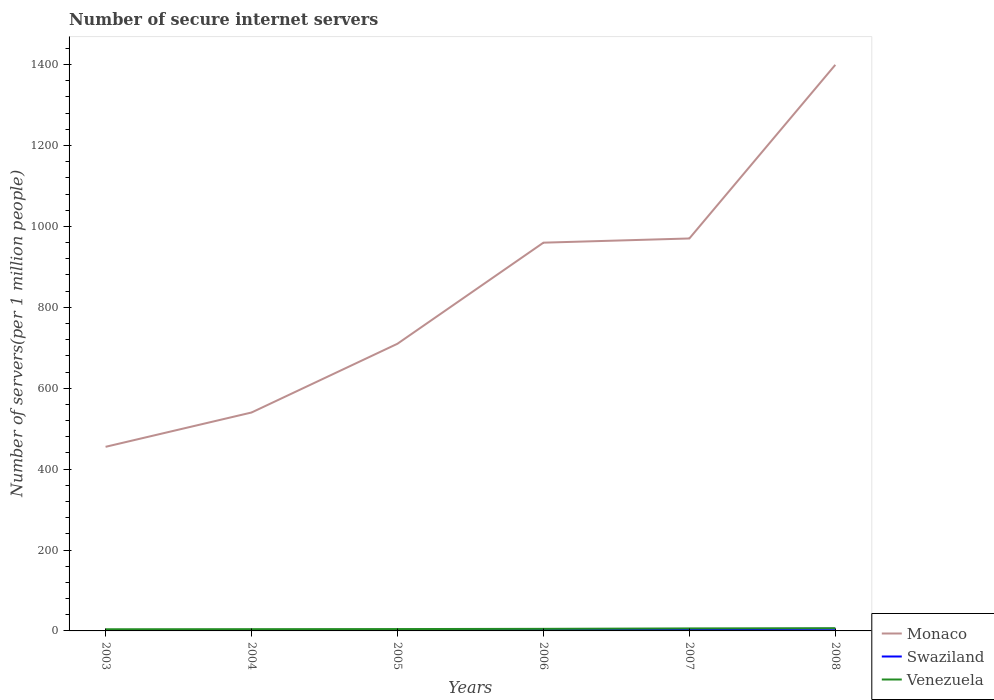How many different coloured lines are there?
Your answer should be compact. 3. Is the number of lines equal to the number of legend labels?
Your answer should be very brief. Yes. Across all years, what is the maximum number of secure internet servers in Swaziland?
Make the answer very short. 1.81. In which year was the number of secure internet servers in Swaziland maximum?
Ensure brevity in your answer.  2005. What is the total number of secure internet servers in Monaco in the graph?
Ensure brevity in your answer.  -10.4. What is the difference between the highest and the second highest number of secure internet servers in Monaco?
Your answer should be very brief. 944.25. What is the difference between the highest and the lowest number of secure internet servers in Venezuela?
Give a very brief answer. 2. Is the number of secure internet servers in Swaziland strictly greater than the number of secure internet servers in Venezuela over the years?
Keep it short and to the point. Yes. How many years are there in the graph?
Your answer should be compact. 6. Are the values on the major ticks of Y-axis written in scientific E-notation?
Offer a very short reply. No. Does the graph contain grids?
Ensure brevity in your answer.  No. Where does the legend appear in the graph?
Give a very brief answer. Bottom right. What is the title of the graph?
Give a very brief answer. Number of secure internet servers. Does "Hungary" appear as one of the legend labels in the graph?
Make the answer very short. No. What is the label or title of the Y-axis?
Your answer should be very brief. Number of servers(per 1 million people). What is the Number of servers(per 1 million people) in Monaco in 2003?
Ensure brevity in your answer.  455.1. What is the Number of servers(per 1 million people) in Swaziland in 2003?
Offer a very short reply. 1.84. What is the Number of servers(per 1 million people) of Venezuela in 2003?
Offer a terse response. 4.1. What is the Number of servers(per 1 million people) of Monaco in 2004?
Offer a terse response. 539.91. What is the Number of servers(per 1 million people) of Swaziland in 2004?
Your answer should be very brief. 1.83. What is the Number of servers(per 1 million people) in Venezuela in 2004?
Your answer should be compact. 4.33. What is the Number of servers(per 1 million people) of Monaco in 2005?
Offer a very short reply. 709.89. What is the Number of servers(per 1 million people) of Swaziland in 2005?
Give a very brief answer. 1.81. What is the Number of servers(per 1 million people) in Venezuela in 2005?
Offer a very short reply. 4.59. What is the Number of servers(per 1 million people) of Monaco in 2006?
Keep it short and to the point. 959.75. What is the Number of servers(per 1 million people) in Swaziland in 2006?
Offer a terse response. 4.47. What is the Number of servers(per 1 million people) in Venezuela in 2006?
Ensure brevity in your answer.  5.14. What is the Number of servers(per 1 million people) in Monaco in 2007?
Provide a succinct answer. 970.15. What is the Number of servers(per 1 million people) in Swaziland in 2007?
Offer a terse response. 4.41. What is the Number of servers(per 1 million people) of Venezuela in 2007?
Offer a very short reply. 6.18. What is the Number of servers(per 1 million people) in Monaco in 2008?
Your answer should be very brief. 1399.35. What is the Number of servers(per 1 million people) of Swaziland in 2008?
Offer a very short reply. 5.2. What is the Number of servers(per 1 million people) of Venezuela in 2008?
Give a very brief answer. 6.72. Across all years, what is the maximum Number of servers(per 1 million people) in Monaco?
Offer a terse response. 1399.35. Across all years, what is the maximum Number of servers(per 1 million people) in Swaziland?
Give a very brief answer. 5.2. Across all years, what is the maximum Number of servers(per 1 million people) of Venezuela?
Your response must be concise. 6.72. Across all years, what is the minimum Number of servers(per 1 million people) in Monaco?
Provide a short and direct response. 455.1. Across all years, what is the minimum Number of servers(per 1 million people) in Swaziland?
Give a very brief answer. 1.81. Across all years, what is the minimum Number of servers(per 1 million people) in Venezuela?
Offer a very short reply. 4.1. What is the total Number of servers(per 1 million people) in Monaco in the graph?
Provide a succinct answer. 5034.14. What is the total Number of servers(per 1 million people) of Swaziland in the graph?
Your answer should be compact. 19.55. What is the total Number of servers(per 1 million people) of Venezuela in the graph?
Make the answer very short. 31.07. What is the difference between the Number of servers(per 1 million people) in Monaco in 2003 and that in 2004?
Provide a succinct answer. -84.81. What is the difference between the Number of servers(per 1 million people) of Swaziland in 2003 and that in 2004?
Provide a succinct answer. 0.01. What is the difference between the Number of servers(per 1 million people) in Venezuela in 2003 and that in 2004?
Provide a short and direct response. -0.23. What is the difference between the Number of servers(per 1 million people) of Monaco in 2003 and that in 2005?
Your answer should be compact. -254.79. What is the difference between the Number of servers(per 1 million people) in Swaziland in 2003 and that in 2005?
Offer a very short reply. 0.03. What is the difference between the Number of servers(per 1 million people) in Venezuela in 2003 and that in 2005?
Your answer should be compact. -0.5. What is the difference between the Number of servers(per 1 million people) of Monaco in 2003 and that in 2006?
Keep it short and to the point. -504.65. What is the difference between the Number of servers(per 1 million people) in Swaziland in 2003 and that in 2006?
Offer a terse response. -2.63. What is the difference between the Number of servers(per 1 million people) in Venezuela in 2003 and that in 2006?
Your answer should be compact. -1.04. What is the difference between the Number of servers(per 1 million people) in Monaco in 2003 and that in 2007?
Give a very brief answer. -515.06. What is the difference between the Number of servers(per 1 million people) in Swaziland in 2003 and that in 2007?
Offer a terse response. -2.57. What is the difference between the Number of servers(per 1 million people) of Venezuela in 2003 and that in 2007?
Your response must be concise. -2.08. What is the difference between the Number of servers(per 1 million people) in Monaco in 2003 and that in 2008?
Provide a short and direct response. -944.25. What is the difference between the Number of servers(per 1 million people) of Swaziland in 2003 and that in 2008?
Give a very brief answer. -3.36. What is the difference between the Number of servers(per 1 million people) in Venezuela in 2003 and that in 2008?
Keep it short and to the point. -2.62. What is the difference between the Number of servers(per 1 million people) in Monaco in 2004 and that in 2005?
Your answer should be compact. -169.98. What is the difference between the Number of servers(per 1 million people) in Swaziland in 2004 and that in 2005?
Offer a very short reply. 0.02. What is the difference between the Number of servers(per 1 million people) in Venezuela in 2004 and that in 2005?
Keep it short and to the point. -0.26. What is the difference between the Number of servers(per 1 million people) of Monaco in 2004 and that in 2006?
Give a very brief answer. -419.84. What is the difference between the Number of servers(per 1 million people) in Swaziland in 2004 and that in 2006?
Provide a succinct answer. -2.64. What is the difference between the Number of servers(per 1 million people) of Venezuela in 2004 and that in 2006?
Make the answer very short. -0.81. What is the difference between the Number of servers(per 1 million people) of Monaco in 2004 and that in 2007?
Your answer should be very brief. -430.25. What is the difference between the Number of servers(per 1 million people) of Swaziland in 2004 and that in 2007?
Offer a very short reply. -2.58. What is the difference between the Number of servers(per 1 million people) in Venezuela in 2004 and that in 2007?
Your response must be concise. -1.85. What is the difference between the Number of servers(per 1 million people) in Monaco in 2004 and that in 2008?
Give a very brief answer. -859.44. What is the difference between the Number of servers(per 1 million people) of Swaziland in 2004 and that in 2008?
Keep it short and to the point. -3.37. What is the difference between the Number of servers(per 1 million people) in Venezuela in 2004 and that in 2008?
Make the answer very short. -2.39. What is the difference between the Number of servers(per 1 million people) in Monaco in 2005 and that in 2006?
Your answer should be compact. -249.86. What is the difference between the Number of servers(per 1 million people) of Swaziland in 2005 and that in 2006?
Make the answer very short. -2.66. What is the difference between the Number of servers(per 1 million people) in Venezuela in 2005 and that in 2006?
Make the answer very short. -0.55. What is the difference between the Number of servers(per 1 million people) of Monaco in 2005 and that in 2007?
Provide a succinct answer. -260.26. What is the difference between the Number of servers(per 1 million people) of Swaziland in 2005 and that in 2007?
Your response must be concise. -2.6. What is the difference between the Number of servers(per 1 million people) in Venezuela in 2005 and that in 2007?
Your answer should be compact. -1.58. What is the difference between the Number of servers(per 1 million people) of Monaco in 2005 and that in 2008?
Your answer should be compact. -689.45. What is the difference between the Number of servers(per 1 million people) in Swaziland in 2005 and that in 2008?
Your answer should be very brief. -3.39. What is the difference between the Number of servers(per 1 million people) in Venezuela in 2005 and that in 2008?
Your answer should be very brief. -2.13. What is the difference between the Number of servers(per 1 million people) in Monaco in 2006 and that in 2007?
Give a very brief answer. -10.4. What is the difference between the Number of servers(per 1 million people) in Swaziland in 2006 and that in 2007?
Offer a very short reply. 0.07. What is the difference between the Number of servers(per 1 million people) of Venezuela in 2006 and that in 2007?
Keep it short and to the point. -1.04. What is the difference between the Number of servers(per 1 million people) in Monaco in 2006 and that in 2008?
Your answer should be compact. -439.6. What is the difference between the Number of servers(per 1 million people) in Swaziland in 2006 and that in 2008?
Your answer should be very brief. -0.73. What is the difference between the Number of servers(per 1 million people) of Venezuela in 2006 and that in 2008?
Offer a very short reply. -1.58. What is the difference between the Number of servers(per 1 million people) in Monaco in 2007 and that in 2008?
Your response must be concise. -429.19. What is the difference between the Number of servers(per 1 million people) in Swaziland in 2007 and that in 2008?
Provide a succinct answer. -0.79. What is the difference between the Number of servers(per 1 million people) of Venezuela in 2007 and that in 2008?
Offer a terse response. -0.54. What is the difference between the Number of servers(per 1 million people) in Monaco in 2003 and the Number of servers(per 1 million people) in Swaziland in 2004?
Your answer should be compact. 453.27. What is the difference between the Number of servers(per 1 million people) of Monaco in 2003 and the Number of servers(per 1 million people) of Venezuela in 2004?
Your answer should be very brief. 450.76. What is the difference between the Number of servers(per 1 million people) of Swaziland in 2003 and the Number of servers(per 1 million people) of Venezuela in 2004?
Make the answer very short. -2.49. What is the difference between the Number of servers(per 1 million people) in Monaco in 2003 and the Number of servers(per 1 million people) in Swaziland in 2005?
Your answer should be very brief. 453.29. What is the difference between the Number of servers(per 1 million people) of Monaco in 2003 and the Number of servers(per 1 million people) of Venezuela in 2005?
Offer a very short reply. 450.5. What is the difference between the Number of servers(per 1 million people) in Swaziland in 2003 and the Number of servers(per 1 million people) in Venezuela in 2005?
Offer a very short reply. -2.76. What is the difference between the Number of servers(per 1 million people) of Monaco in 2003 and the Number of servers(per 1 million people) of Swaziland in 2006?
Offer a terse response. 450.63. What is the difference between the Number of servers(per 1 million people) of Monaco in 2003 and the Number of servers(per 1 million people) of Venezuela in 2006?
Make the answer very short. 449.95. What is the difference between the Number of servers(per 1 million people) of Swaziland in 2003 and the Number of servers(per 1 million people) of Venezuela in 2006?
Your answer should be very brief. -3.3. What is the difference between the Number of servers(per 1 million people) in Monaco in 2003 and the Number of servers(per 1 million people) in Swaziland in 2007?
Your answer should be compact. 450.69. What is the difference between the Number of servers(per 1 million people) in Monaco in 2003 and the Number of servers(per 1 million people) in Venezuela in 2007?
Ensure brevity in your answer.  448.92. What is the difference between the Number of servers(per 1 million people) of Swaziland in 2003 and the Number of servers(per 1 million people) of Venezuela in 2007?
Offer a very short reply. -4.34. What is the difference between the Number of servers(per 1 million people) of Monaco in 2003 and the Number of servers(per 1 million people) of Swaziland in 2008?
Offer a terse response. 449.9. What is the difference between the Number of servers(per 1 million people) in Monaco in 2003 and the Number of servers(per 1 million people) in Venezuela in 2008?
Ensure brevity in your answer.  448.38. What is the difference between the Number of servers(per 1 million people) in Swaziland in 2003 and the Number of servers(per 1 million people) in Venezuela in 2008?
Your answer should be very brief. -4.88. What is the difference between the Number of servers(per 1 million people) of Monaco in 2004 and the Number of servers(per 1 million people) of Swaziland in 2005?
Provide a succinct answer. 538.1. What is the difference between the Number of servers(per 1 million people) in Monaco in 2004 and the Number of servers(per 1 million people) in Venezuela in 2005?
Your response must be concise. 535.31. What is the difference between the Number of servers(per 1 million people) of Swaziland in 2004 and the Number of servers(per 1 million people) of Venezuela in 2005?
Provide a short and direct response. -2.77. What is the difference between the Number of servers(per 1 million people) in Monaco in 2004 and the Number of servers(per 1 million people) in Swaziland in 2006?
Offer a terse response. 535.44. What is the difference between the Number of servers(per 1 million people) in Monaco in 2004 and the Number of servers(per 1 million people) in Venezuela in 2006?
Make the answer very short. 534.77. What is the difference between the Number of servers(per 1 million people) of Swaziland in 2004 and the Number of servers(per 1 million people) of Venezuela in 2006?
Your answer should be compact. -3.32. What is the difference between the Number of servers(per 1 million people) of Monaco in 2004 and the Number of servers(per 1 million people) of Swaziland in 2007?
Your answer should be compact. 535.5. What is the difference between the Number of servers(per 1 million people) in Monaco in 2004 and the Number of servers(per 1 million people) in Venezuela in 2007?
Ensure brevity in your answer.  533.73. What is the difference between the Number of servers(per 1 million people) of Swaziland in 2004 and the Number of servers(per 1 million people) of Venezuela in 2007?
Make the answer very short. -4.35. What is the difference between the Number of servers(per 1 million people) of Monaco in 2004 and the Number of servers(per 1 million people) of Swaziland in 2008?
Keep it short and to the point. 534.71. What is the difference between the Number of servers(per 1 million people) of Monaco in 2004 and the Number of servers(per 1 million people) of Venezuela in 2008?
Offer a very short reply. 533.19. What is the difference between the Number of servers(per 1 million people) of Swaziland in 2004 and the Number of servers(per 1 million people) of Venezuela in 2008?
Your answer should be compact. -4.9. What is the difference between the Number of servers(per 1 million people) of Monaco in 2005 and the Number of servers(per 1 million people) of Swaziland in 2006?
Keep it short and to the point. 705.42. What is the difference between the Number of servers(per 1 million people) in Monaco in 2005 and the Number of servers(per 1 million people) in Venezuela in 2006?
Ensure brevity in your answer.  704.75. What is the difference between the Number of servers(per 1 million people) of Swaziland in 2005 and the Number of servers(per 1 million people) of Venezuela in 2006?
Provide a succinct answer. -3.33. What is the difference between the Number of servers(per 1 million people) of Monaco in 2005 and the Number of servers(per 1 million people) of Swaziland in 2007?
Make the answer very short. 705.49. What is the difference between the Number of servers(per 1 million people) of Monaco in 2005 and the Number of servers(per 1 million people) of Venezuela in 2007?
Your answer should be compact. 703.71. What is the difference between the Number of servers(per 1 million people) in Swaziland in 2005 and the Number of servers(per 1 million people) in Venezuela in 2007?
Offer a terse response. -4.37. What is the difference between the Number of servers(per 1 million people) of Monaco in 2005 and the Number of servers(per 1 million people) of Swaziland in 2008?
Provide a short and direct response. 704.69. What is the difference between the Number of servers(per 1 million people) of Monaco in 2005 and the Number of servers(per 1 million people) of Venezuela in 2008?
Offer a terse response. 703.17. What is the difference between the Number of servers(per 1 million people) of Swaziland in 2005 and the Number of servers(per 1 million people) of Venezuela in 2008?
Offer a very short reply. -4.91. What is the difference between the Number of servers(per 1 million people) in Monaco in 2006 and the Number of servers(per 1 million people) in Swaziland in 2007?
Ensure brevity in your answer.  955.34. What is the difference between the Number of servers(per 1 million people) in Monaco in 2006 and the Number of servers(per 1 million people) in Venezuela in 2007?
Provide a short and direct response. 953.57. What is the difference between the Number of servers(per 1 million people) of Swaziland in 2006 and the Number of servers(per 1 million people) of Venezuela in 2007?
Keep it short and to the point. -1.71. What is the difference between the Number of servers(per 1 million people) of Monaco in 2006 and the Number of servers(per 1 million people) of Swaziland in 2008?
Your answer should be compact. 954.55. What is the difference between the Number of servers(per 1 million people) of Monaco in 2006 and the Number of servers(per 1 million people) of Venezuela in 2008?
Ensure brevity in your answer.  953.03. What is the difference between the Number of servers(per 1 million people) of Swaziland in 2006 and the Number of servers(per 1 million people) of Venezuela in 2008?
Provide a short and direct response. -2.25. What is the difference between the Number of servers(per 1 million people) in Monaco in 2007 and the Number of servers(per 1 million people) in Swaziland in 2008?
Keep it short and to the point. 964.95. What is the difference between the Number of servers(per 1 million people) in Monaco in 2007 and the Number of servers(per 1 million people) in Venezuela in 2008?
Provide a succinct answer. 963.43. What is the difference between the Number of servers(per 1 million people) in Swaziland in 2007 and the Number of servers(per 1 million people) in Venezuela in 2008?
Offer a terse response. -2.32. What is the average Number of servers(per 1 million people) of Monaco per year?
Offer a terse response. 839.02. What is the average Number of servers(per 1 million people) of Swaziland per year?
Make the answer very short. 3.26. What is the average Number of servers(per 1 million people) in Venezuela per year?
Keep it short and to the point. 5.18. In the year 2003, what is the difference between the Number of servers(per 1 million people) of Monaco and Number of servers(per 1 million people) of Swaziland?
Your answer should be compact. 453.26. In the year 2003, what is the difference between the Number of servers(per 1 million people) in Monaco and Number of servers(per 1 million people) in Venezuela?
Your response must be concise. 451. In the year 2003, what is the difference between the Number of servers(per 1 million people) in Swaziland and Number of servers(per 1 million people) in Venezuela?
Your answer should be very brief. -2.26. In the year 2004, what is the difference between the Number of servers(per 1 million people) in Monaco and Number of servers(per 1 million people) in Swaziland?
Offer a very short reply. 538.08. In the year 2004, what is the difference between the Number of servers(per 1 million people) of Monaco and Number of servers(per 1 million people) of Venezuela?
Provide a succinct answer. 535.58. In the year 2004, what is the difference between the Number of servers(per 1 million people) of Swaziland and Number of servers(per 1 million people) of Venezuela?
Provide a short and direct response. -2.51. In the year 2005, what is the difference between the Number of servers(per 1 million people) in Monaco and Number of servers(per 1 million people) in Swaziland?
Your answer should be compact. 708.08. In the year 2005, what is the difference between the Number of servers(per 1 million people) in Monaco and Number of servers(per 1 million people) in Venezuela?
Offer a very short reply. 705.3. In the year 2005, what is the difference between the Number of servers(per 1 million people) in Swaziland and Number of servers(per 1 million people) in Venezuela?
Your response must be concise. -2.78. In the year 2006, what is the difference between the Number of servers(per 1 million people) in Monaco and Number of servers(per 1 million people) in Swaziland?
Keep it short and to the point. 955.28. In the year 2006, what is the difference between the Number of servers(per 1 million people) of Monaco and Number of servers(per 1 million people) of Venezuela?
Offer a very short reply. 954.61. In the year 2006, what is the difference between the Number of servers(per 1 million people) in Swaziland and Number of servers(per 1 million people) in Venezuela?
Offer a very short reply. -0.67. In the year 2007, what is the difference between the Number of servers(per 1 million people) in Monaco and Number of servers(per 1 million people) in Swaziland?
Provide a succinct answer. 965.75. In the year 2007, what is the difference between the Number of servers(per 1 million people) in Monaco and Number of servers(per 1 million people) in Venezuela?
Offer a very short reply. 963.97. In the year 2007, what is the difference between the Number of servers(per 1 million people) in Swaziland and Number of servers(per 1 million people) in Venezuela?
Offer a terse response. -1.77. In the year 2008, what is the difference between the Number of servers(per 1 million people) in Monaco and Number of servers(per 1 million people) in Swaziland?
Your answer should be compact. 1394.14. In the year 2008, what is the difference between the Number of servers(per 1 million people) in Monaco and Number of servers(per 1 million people) in Venezuela?
Your answer should be compact. 1392.62. In the year 2008, what is the difference between the Number of servers(per 1 million people) in Swaziland and Number of servers(per 1 million people) in Venezuela?
Ensure brevity in your answer.  -1.52. What is the ratio of the Number of servers(per 1 million people) in Monaco in 2003 to that in 2004?
Give a very brief answer. 0.84. What is the ratio of the Number of servers(per 1 million people) in Venezuela in 2003 to that in 2004?
Offer a very short reply. 0.95. What is the ratio of the Number of servers(per 1 million people) of Monaco in 2003 to that in 2005?
Make the answer very short. 0.64. What is the ratio of the Number of servers(per 1 million people) in Swaziland in 2003 to that in 2005?
Your answer should be very brief. 1.02. What is the ratio of the Number of servers(per 1 million people) of Venezuela in 2003 to that in 2005?
Provide a short and direct response. 0.89. What is the ratio of the Number of servers(per 1 million people) in Monaco in 2003 to that in 2006?
Make the answer very short. 0.47. What is the ratio of the Number of servers(per 1 million people) of Swaziland in 2003 to that in 2006?
Provide a short and direct response. 0.41. What is the ratio of the Number of servers(per 1 million people) in Venezuela in 2003 to that in 2006?
Make the answer very short. 0.8. What is the ratio of the Number of servers(per 1 million people) of Monaco in 2003 to that in 2007?
Make the answer very short. 0.47. What is the ratio of the Number of servers(per 1 million people) in Swaziland in 2003 to that in 2007?
Your answer should be compact. 0.42. What is the ratio of the Number of servers(per 1 million people) in Venezuela in 2003 to that in 2007?
Ensure brevity in your answer.  0.66. What is the ratio of the Number of servers(per 1 million people) in Monaco in 2003 to that in 2008?
Keep it short and to the point. 0.33. What is the ratio of the Number of servers(per 1 million people) of Swaziland in 2003 to that in 2008?
Your answer should be very brief. 0.35. What is the ratio of the Number of servers(per 1 million people) in Venezuela in 2003 to that in 2008?
Offer a very short reply. 0.61. What is the ratio of the Number of servers(per 1 million people) of Monaco in 2004 to that in 2005?
Provide a short and direct response. 0.76. What is the ratio of the Number of servers(per 1 million people) of Swaziland in 2004 to that in 2005?
Your answer should be compact. 1.01. What is the ratio of the Number of servers(per 1 million people) of Venezuela in 2004 to that in 2005?
Give a very brief answer. 0.94. What is the ratio of the Number of servers(per 1 million people) in Monaco in 2004 to that in 2006?
Ensure brevity in your answer.  0.56. What is the ratio of the Number of servers(per 1 million people) of Swaziland in 2004 to that in 2006?
Ensure brevity in your answer.  0.41. What is the ratio of the Number of servers(per 1 million people) in Venezuela in 2004 to that in 2006?
Ensure brevity in your answer.  0.84. What is the ratio of the Number of servers(per 1 million people) in Monaco in 2004 to that in 2007?
Ensure brevity in your answer.  0.56. What is the ratio of the Number of servers(per 1 million people) of Swaziland in 2004 to that in 2007?
Your answer should be compact. 0.41. What is the ratio of the Number of servers(per 1 million people) of Venezuela in 2004 to that in 2007?
Give a very brief answer. 0.7. What is the ratio of the Number of servers(per 1 million people) in Monaco in 2004 to that in 2008?
Your answer should be very brief. 0.39. What is the ratio of the Number of servers(per 1 million people) in Swaziland in 2004 to that in 2008?
Give a very brief answer. 0.35. What is the ratio of the Number of servers(per 1 million people) in Venezuela in 2004 to that in 2008?
Make the answer very short. 0.64. What is the ratio of the Number of servers(per 1 million people) of Monaco in 2005 to that in 2006?
Ensure brevity in your answer.  0.74. What is the ratio of the Number of servers(per 1 million people) in Swaziland in 2005 to that in 2006?
Your response must be concise. 0.4. What is the ratio of the Number of servers(per 1 million people) in Venezuela in 2005 to that in 2006?
Offer a very short reply. 0.89. What is the ratio of the Number of servers(per 1 million people) in Monaco in 2005 to that in 2007?
Your answer should be compact. 0.73. What is the ratio of the Number of servers(per 1 million people) of Swaziland in 2005 to that in 2007?
Your response must be concise. 0.41. What is the ratio of the Number of servers(per 1 million people) of Venezuela in 2005 to that in 2007?
Your response must be concise. 0.74. What is the ratio of the Number of servers(per 1 million people) of Monaco in 2005 to that in 2008?
Provide a short and direct response. 0.51. What is the ratio of the Number of servers(per 1 million people) in Swaziland in 2005 to that in 2008?
Provide a succinct answer. 0.35. What is the ratio of the Number of servers(per 1 million people) of Venezuela in 2005 to that in 2008?
Offer a terse response. 0.68. What is the ratio of the Number of servers(per 1 million people) of Monaco in 2006 to that in 2007?
Ensure brevity in your answer.  0.99. What is the ratio of the Number of servers(per 1 million people) of Swaziland in 2006 to that in 2007?
Your response must be concise. 1.01. What is the ratio of the Number of servers(per 1 million people) in Venezuela in 2006 to that in 2007?
Give a very brief answer. 0.83. What is the ratio of the Number of servers(per 1 million people) of Monaco in 2006 to that in 2008?
Give a very brief answer. 0.69. What is the ratio of the Number of servers(per 1 million people) of Swaziland in 2006 to that in 2008?
Make the answer very short. 0.86. What is the ratio of the Number of servers(per 1 million people) in Venezuela in 2006 to that in 2008?
Make the answer very short. 0.77. What is the ratio of the Number of servers(per 1 million people) in Monaco in 2007 to that in 2008?
Your answer should be very brief. 0.69. What is the ratio of the Number of servers(per 1 million people) in Swaziland in 2007 to that in 2008?
Ensure brevity in your answer.  0.85. What is the ratio of the Number of servers(per 1 million people) in Venezuela in 2007 to that in 2008?
Your answer should be compact. 0.92. What is the difference between the highest and the second highest Number of servers(per 1 million people) of Monaco?
Make the answer very short. 429.19. What is the difference between the highest and the second highest Number of servers(per 1 million people) in Swaziland?
Offer a very short reply. 0.73. What is the difference between the highest and the second highest Number of servers(per 1 million people) in Venezuela?
Provide a succinct answer. 0.54. What is the difference between the highest and the lowest Number of servers(per 1 million people) of Monaco?
Your answer should be compact. 944.25. What is the difference between the highest and the lowest Number of servers(per 1 million people) in Swaziland?
Your answer should be compact. 3.39. What is the difference between the highest and the lowest Number of servers(per 1 million people) in Venezuela?
Your response must be concise. 2.62. 